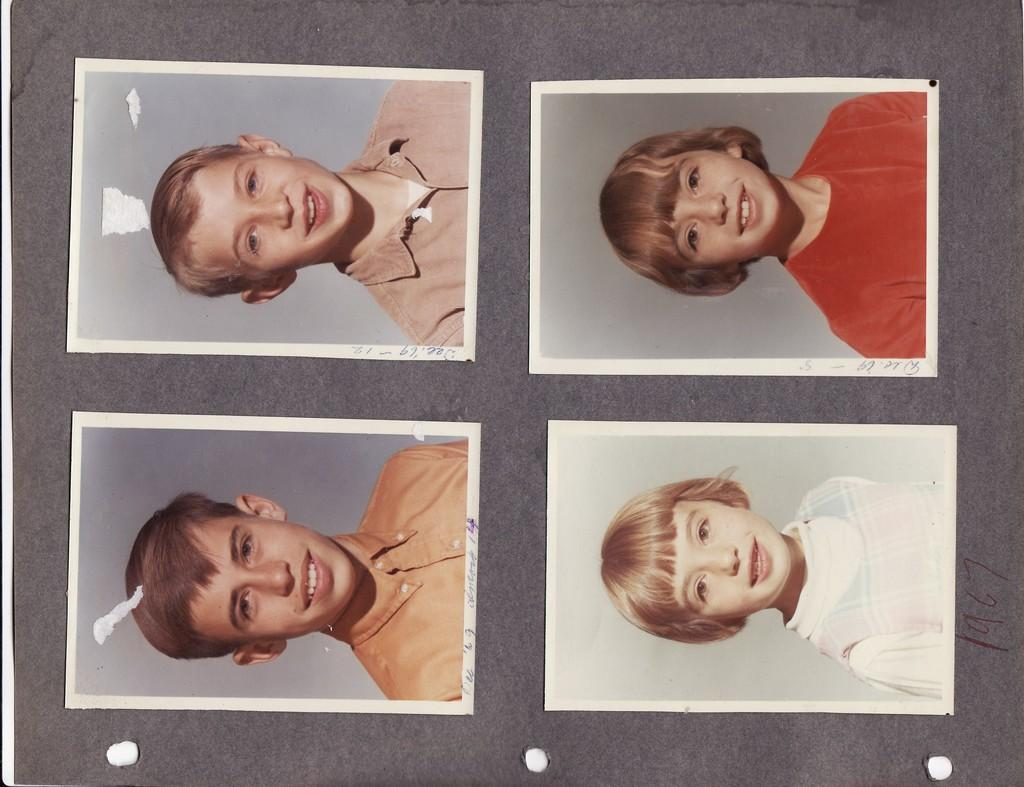How many people are present in the image? There are four persons in the image. What type of rings can be seen on the sheep in the image? There are no sheep or rings present in the image; it features four persons. 